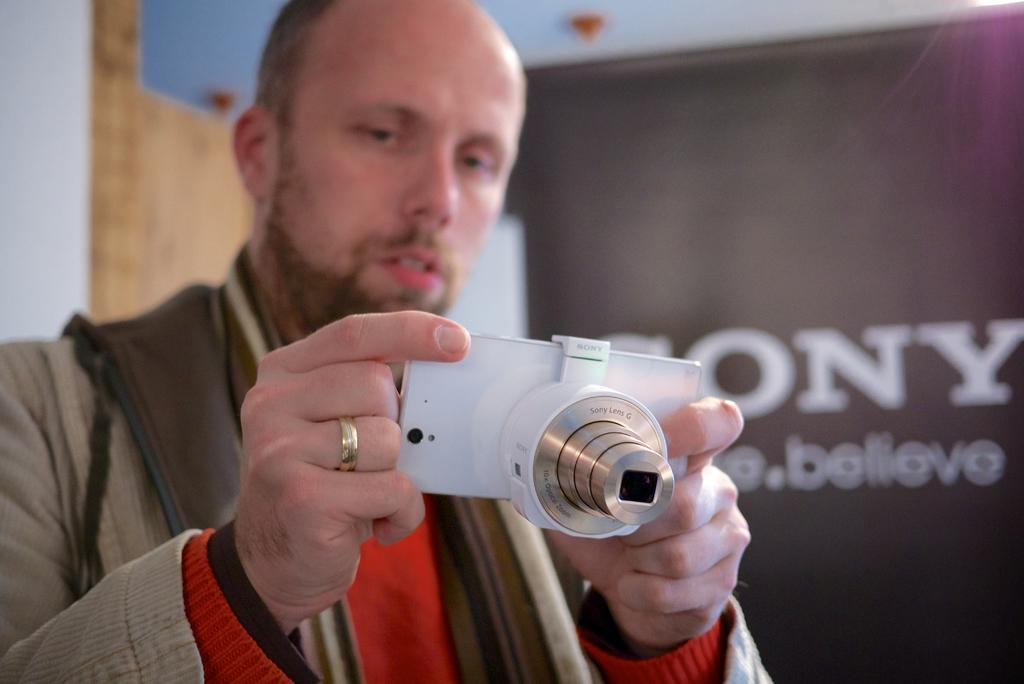Who is present in the image? There is a man in the image. What is the man holding in the image? The man is holding a camera. What is the man doing with the camera? The man is taking a snap. What else can be seen in the image besides the man and the camera? There is a banner in the image. What type of cushion is being used to support the camera in the image? There is no cushion present in the image, and the camera is being held by the man. 